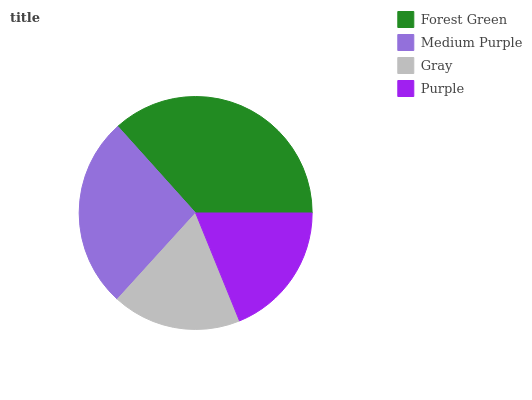Is Gray the minimum?
Answer yes or no. Yes. Is Forest Green the maximum?
Answer yes or no. Yes. Is Medium Purple the minimum?
Answer yes or no. No. Is Medium Purple the maximum?
Answer yes or no. No. Is Forest Green greater than Medium Purple?
Answer yes or no. Yes. Is Medium Purple less than Forest Green?
Answer yes or no. Yes. Is Medium Purple greater than Forest Green?
Answer yes or no. No. Is Forest Green less than Medium Purple?
Answer yes or no. No. Is Medium Purple the high median?
Answer yes or no. Yes. Is Purple the low median?
Answer yes or no. Yes. Is Purple the high median?
Answer yes or no. No. Is Forest Green the low median?
Answer yes or no. No. 